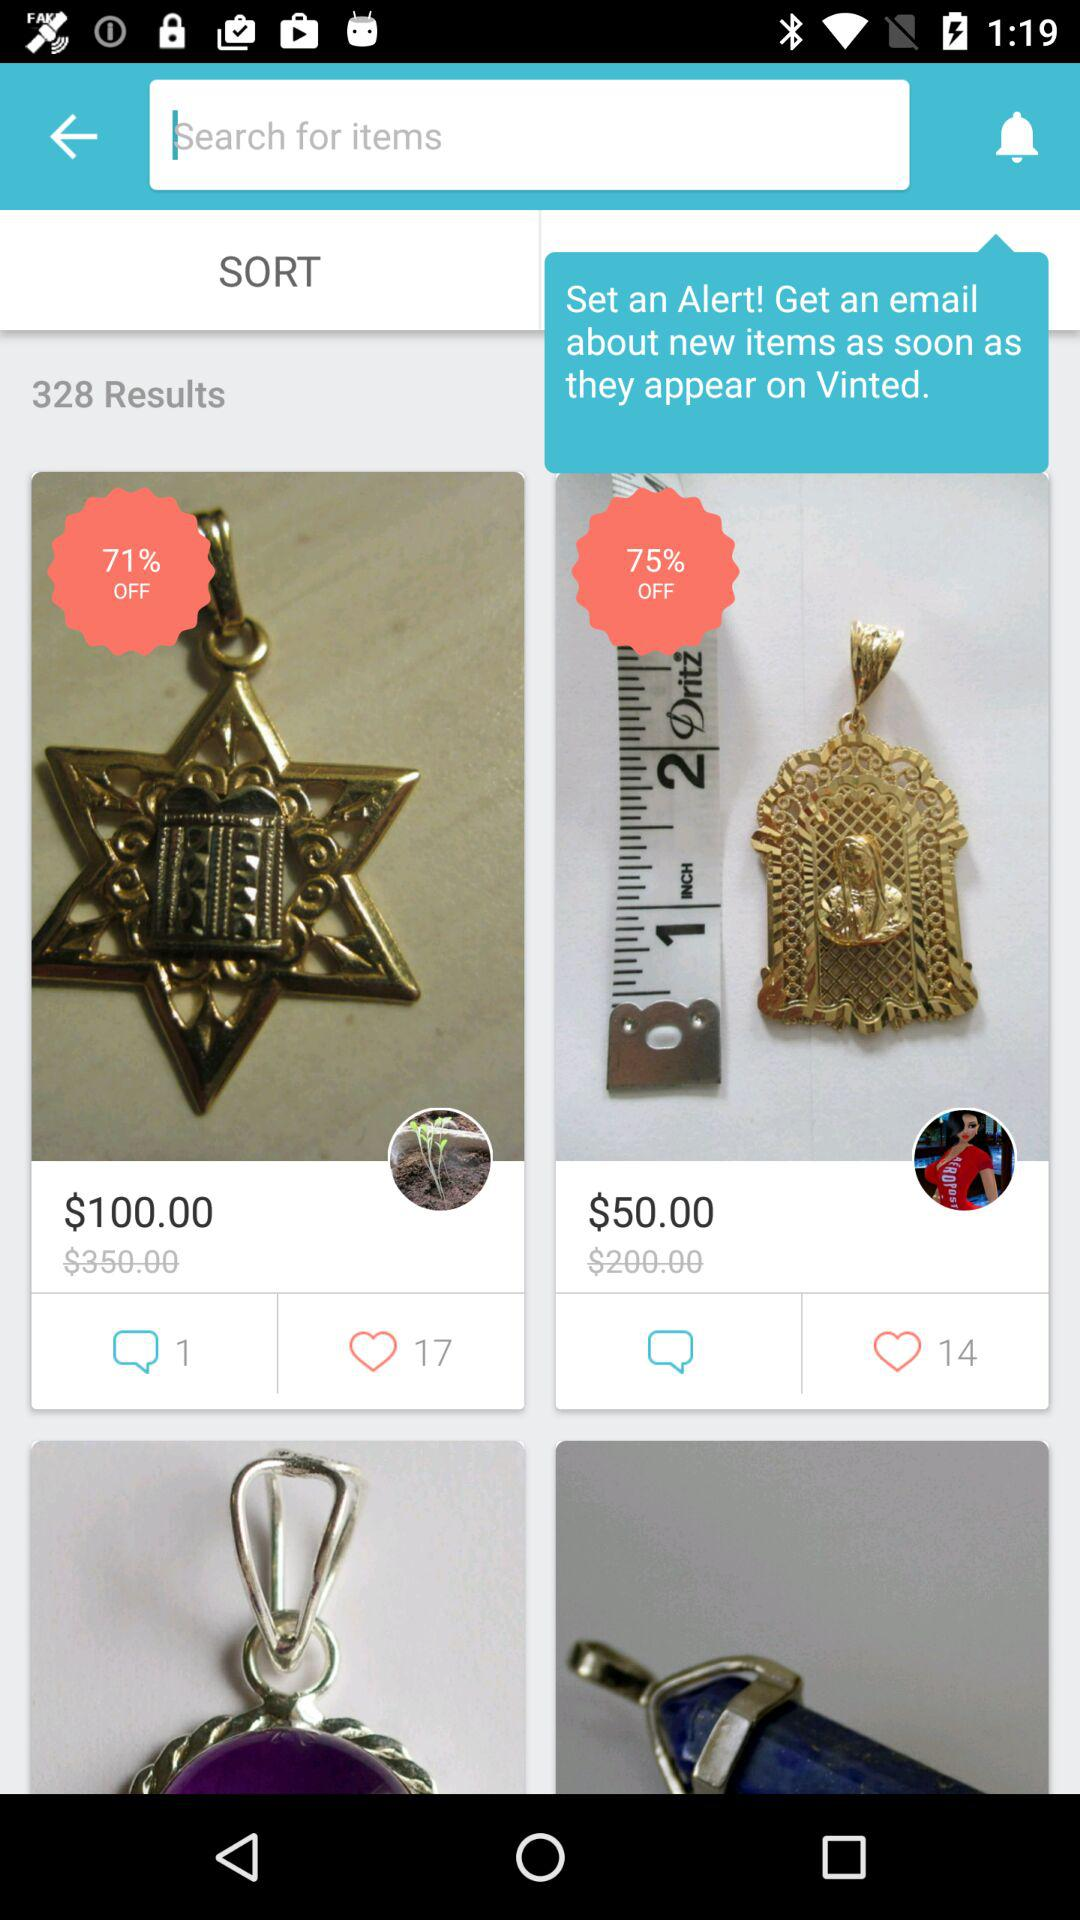How many results are shown? The number of results shown is 328. 